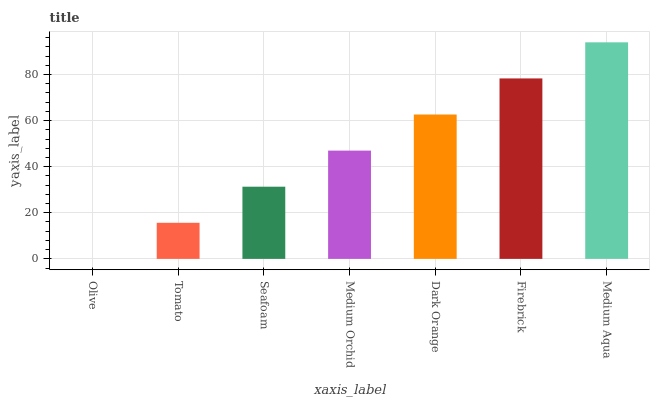Is Olive the minimum?
Answer yes or no. Yes. Is Medium Aqua the maximum?
Answer yes or no. Yes. Is Tomato the minimum?
Answer yes or no. No. Is Tomato the maximum?
Answer yes or no. No. Is Tomato greater than Olive?
Answer yes or no. Yes. Is Olive less than Tomato?
Answer yes or no. Yes. Is Olive greater than Tomato?
Answer yes or no. No. Is Tomato less than Olive?
Answer yes or no. No. Is Medium Orchid the high median?
Answer yes or no. Yes. Is Medium Orchid the low median?
Answer yes or no. Yes. Is Medium Aqua the high median?
Answer yes or no. No. Is Firebrick the low median?
Answer yes or no. No. 